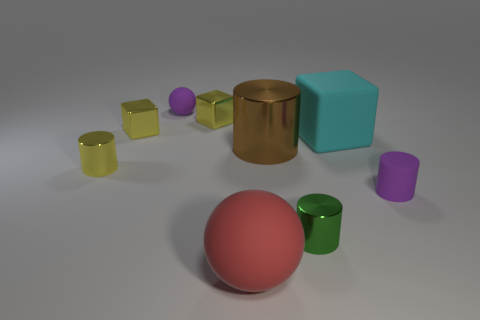Subtract all blocks. How many objects are left? 6 Add 8 purple spheres. How many purple spheres exist? 9 Subtract 0 purple blocks. How many objects are left? 9 Subtract all big cyan objects. Subtract all yellow shiny cylinders. How many objects are left? 7 Add 3 large red matte spheres. How many large red matte spheres are left? 4 